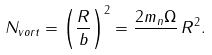Convert formula to latex. <formula><loc_0><loc_0><loc_500><loc_500>N _ { v o r t } = \left ( \frac { R } { b } \right ) ^ { 2 } = \frac { 2 m _ { n } \Omega } { } \, R ^ { 2 } .</formula> 